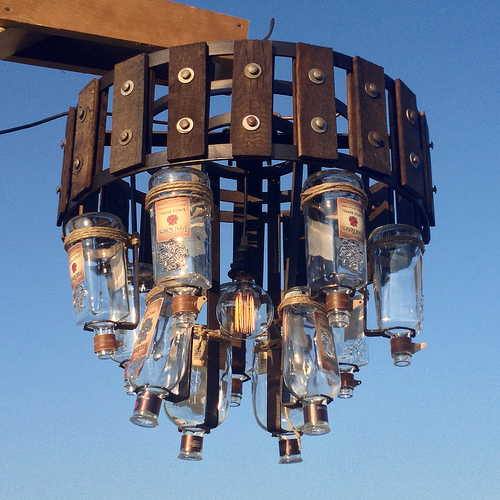<image>
Is the bottle next to the bottle? Yes. The bottle is positioned adjacent to the bottle, located nearby in the same general area. Where is the glass bottle in relation to the metal band? Is it on the metal band? No. The glass bottle is not positioned on the metal band. They may be near each other, but the glass bottle is not supported by or resting on top of the metal band. 